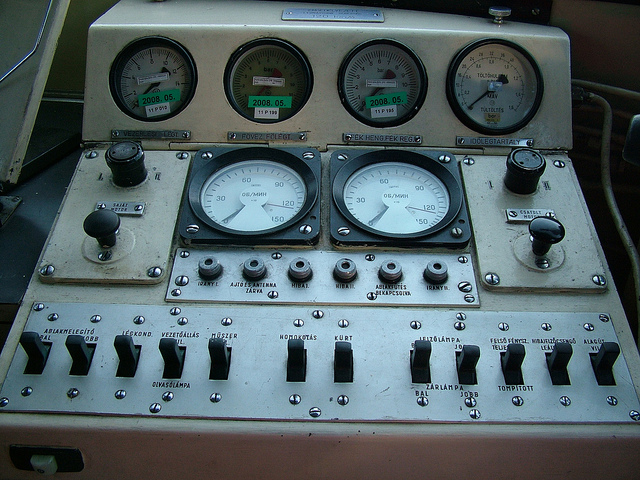Identify the text contained in this image. 2008 05 2008 OOLEGTARIALY 120 BAL JOBB TOMPITOFF TEUE LELZULAMPA CURT SLVASCLAMPA 30 